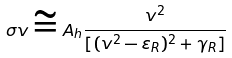Convert formula to latex. <formula><loc_0><loc_0><loc_500><loc_500>\sigma v \cong A _ { h } \frac { v ^ { 2 } } { [ ( v ^ { 2 } - \varepsilon _ { R } ) ^ { 2 } + \gamma _ { R } ] }</formula> 